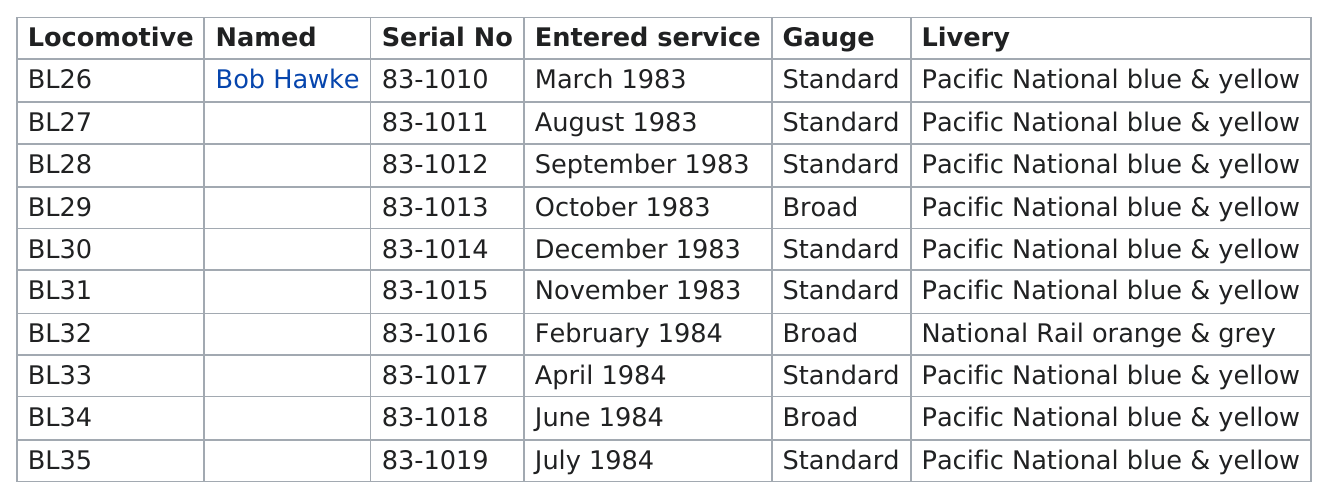Mention a couple of crucial points in this snapshot. Out of the total number of locomotives, only 3 are not standard gauge. In 1983, six locomotives were placed in service. The first year the vehicle entered service was 1983. BL26 is the oldest locomotive. After the BL31 event, a total of 4 locomotives were put into service. 